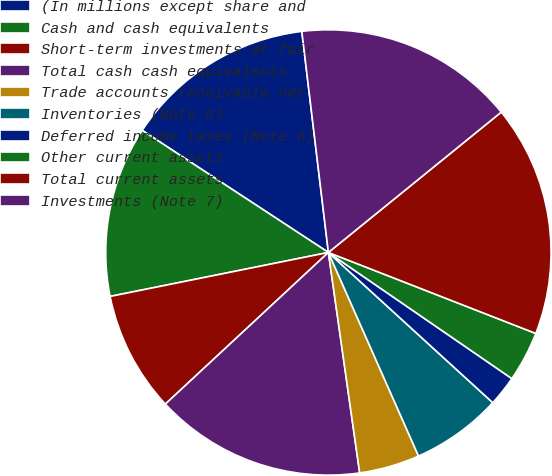<chart> <loc_0><loc_0><loc_500><loc_500><pie_chart><fcel>(In millions except share and<fcel>Cash and cash equivalents<fcel>Short-term investments at fair<fcel>Total cash cash equivalents<fcel>Trade accounts receivable net<fcel>Inventories (Note 5)<fcel>Deferred income taxes (Note 6)<fcel>Other current assets<fcel>Total current assets<fcel>Investments (Note 7)<nl><fcel>13.86%<fcel>12.4%<fcel>8.76%<fcel>15.32%<fcel>4.39%<fcel>6.58%<fcel>2.2%<fcel>3.66%<fcel>16.78%<fcel>16.05%<nl></chart> 